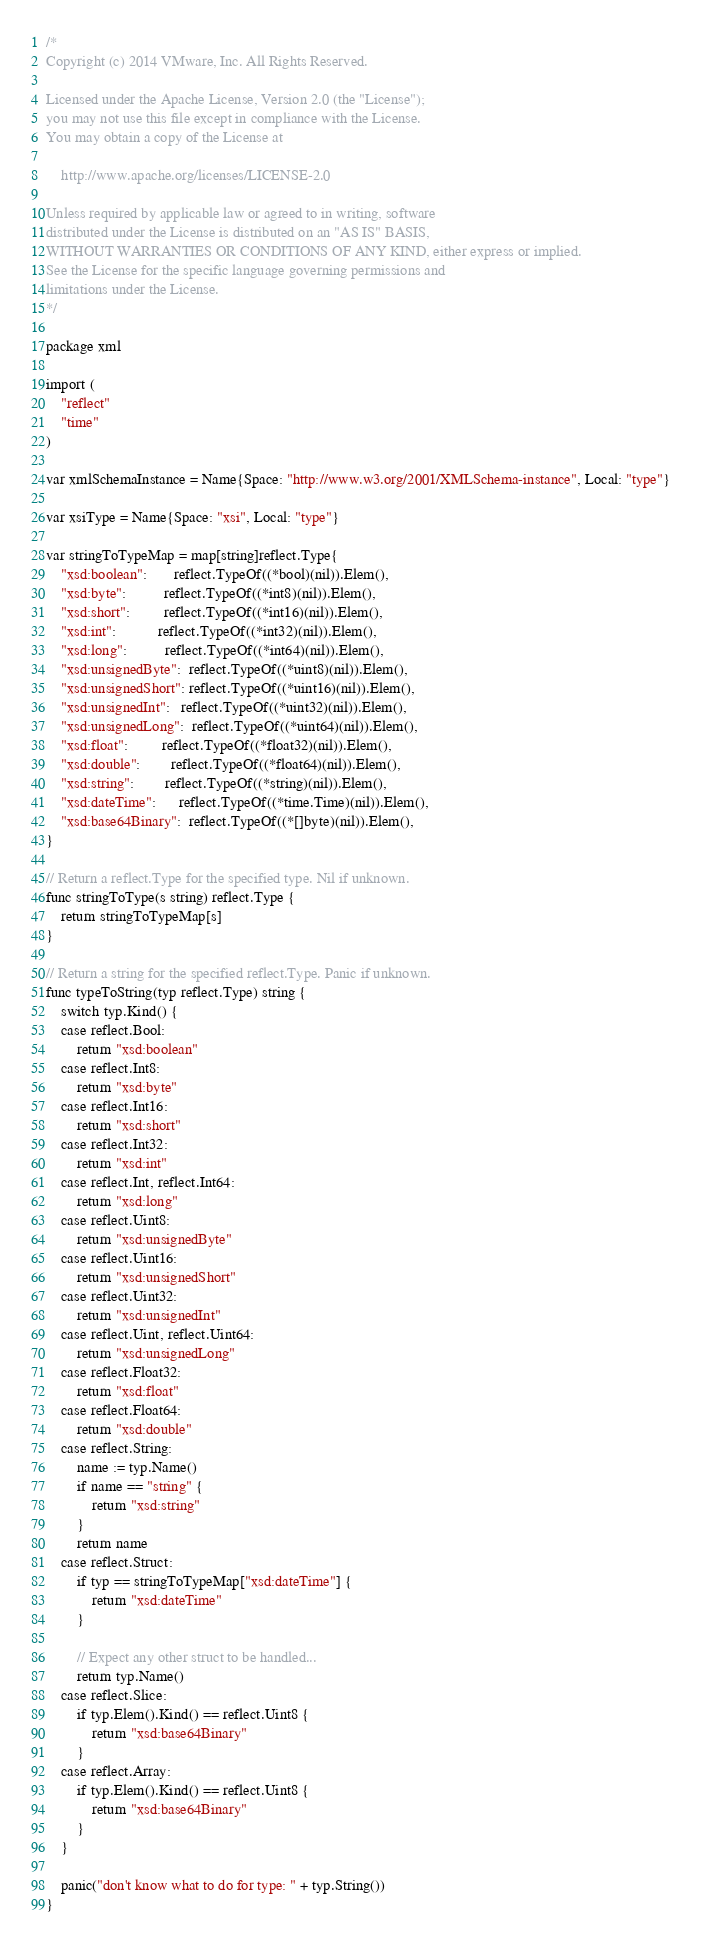<code> <loc_0><loc_0><loc_500><loc_500><_Go_>/*
Copyright (c) 2014 VMware, Inc. All Rights Reserved.

Licensed under the Apache License, Version 2.0 (the "License");
you may not use this file except in compliance with the License.
You may obtain a copy of the License at

    http://www.apache.org/licenses/LICENSE-2.0

Unless required by applicable law or agreed to in writing, software
distributed under the License is distributed on an "AS IS" BASIS,
WITHOUT WARRANTIES OR CONDITIONS OF ANY KIND, either express or implied.
See the License for the specific language governing permissions and
limitations under the License.
*/

package xml

import (
	"reflect"
	"time"
)

var xmlSchemaInstance = Name{Space: "http://www.w3.org/2001/XMLSchema-instance", Local: "type"}

var xsiType = Name{Space: "xsi", Local: "type"}

var stringToTypeMap = map[string]reflect.Type{
	"xsd:boolean":       reflect.TypeOf((*bool)(nil)).Elem(),
	"xsd:byte":          reflect.TypeOf((*int8)(nil)).Elem(),
	"xsd:short":         reflect.TypeOf((*int16)(nil)).Elem(),
	"xsd:int":           reflect.TypeOf((*int32)(nil)).Elem(),
	"xsd:long":          reflect.TypeOf((*int64)(nil)).Elem(),
	"xsd:unsignedByte":  reflect.TypeOf((*uint8)(nil)).Elem(),
	"xsd:unsignedShort": reflect.TypeOf((*uint16)(nil)).Elem(),
	"xsd:unsignedInt":   reflect.TypeOf((*uint32)(nil)).Elem(),
	"xsd:unsignedLong":  reflect.TypeOf((*uint64)(nil)).Elem(),
	"xsd:float":         reflect.TypeOf((*float32)(nil)).Elem(),
	"xsd:double":        reflect.TypeOf((*float64)(nil)).Elem(),
	"xsd:string":        reflect.TypeOf((*string)(nil)).Elem(),
	"xsd:dateTime":      reflect.TypeOf((*time.Time)(nil)).Elem(),
	"xsd:base64Binary":  reflect.TypeOf((*[]byte)(nil)).Elem(),
}

// Return a reflect.Type for the specified type. Nil if unknown.
func stringToType(s string) reflect.Type {
	return stringToTypeMap[s]
}

// Return a string for the specified reflect.Type. Panic if unknown.
func typeToString(typ reflect.Type) string {
	switch typ.Kind() {
	case reflect.Bool:
		return "xsd:boolean"
	case reflect.Int8:
		return "xsd:byte"
	case reflect.Int16:
		return "xsd:short"
	case reflect.Int32:
		return "xsd:int"
	case reflect.Int, reflect.Int64:
		return "xsd:long"
	case reflect.Uint8:
		return "xsd:unsignedByte"
	case reflect.Uint16:
		return "xsd:unsignedShort"
	case reflect.Uint32:
		return "xsd:unsignedInt"
	case reflect.Uint, reflect.Uint64:
		return "xsd:unsignedLong"
	case reflect.Float32:
		return "xsd:float"
	case reflect.Float64:
		return "xsd:double"
	case reflect.String:
		name := typ.Name()
		if name == "string" {
			return "xsd:string"
		}
		return name
	case reflect.Struct:
		if typ == stringToTypeMap["xsd:dateTime"] {
			return "xsd:dateTime"
		}

		// Expect any other struct to be handled...
		return typ.Name()
	case reflect.Slice:
		if typ.Elem().Kind() == reflect.Uint8 {
			return "xsd:base64Binary"
		}
	case reflect.Array:
		if typ.Elem().Kind() == reflect.Uint8 {
			return "xsd:base64Binary"
		}
	}

	panic("don't know what to do for type: " + typ.String())
}
</code> 